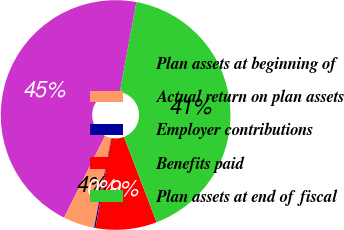<chart> <loc_0><loc_0><loc_500><loc_500><pie_chart><fcel>Plan assets at beginning of<fcel>Actual return on plan assets<fcel>Employer contributions<fcel>Benefits paid<fcel>Plan assets at end of fiscal<nl><fcel>45.49%<fcel>4.41%<fcel>0.2%<fcel>8.62%<fcel>41.28%<nl></chart> 